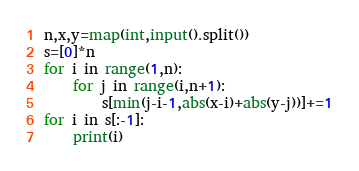<code> <loc_0><loc_0><loc_500><loc_500><_Python_>n,x,y=map(int,input().split())
s=[0]*n
for i in range(1,n):
    for j in range(i,n+1):
        s[min(j-i-1,abs(x-i)+abs(y-j))]+=1
for i in s[:-1]:
    print(i)</code> 